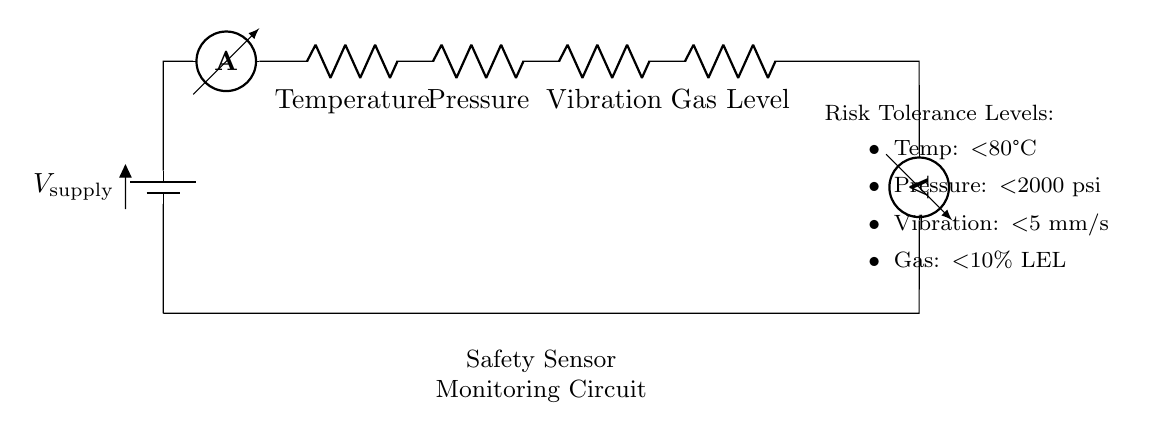What is the type of circuit depicted? The circuit is a series circuit, where all components (sensors and ammeter) are connected in a single path for current flow.
Answer: series circuit How many safety sensors are monitored? There are four safety sensors connected in series: Temperature, Pressure, Vibration, and Gas Level.
Answer: four What is the maximum allowable temperature for the safety sensor? The circuit specifies a risk tolerance level for temperature as less than 80 degrees Celsius, based on safety standards.
Answer: less than 80 degrees Celsius What is the role of the ammeter in the circuit? The ammeter measures the current flowing through the circuit, allowing monitoring of the total current as it passes through each sensor.
Answer: measures current If one sensor fails, what happens to the other sensors? In a series circuit, if one sensor fails (opens the circuit), all sensors will cease to function as current cannot flow through the circuit.
Answer: all sensors cease to function What does the voltmeter measure in this circuit? The voltmeter measures the total voltage drop across the entire circuit to assess the performance and functionality of the connected sensors.
Answer: measures total voltage drop What is the significance of setting risk tolerance levels? Risk tolerance levels help in defining acceptable operational limits for each sensor, ensuring safety and timely responses to potential hazards in the manufacturing plant.
Answer: define acceptable operational limits 